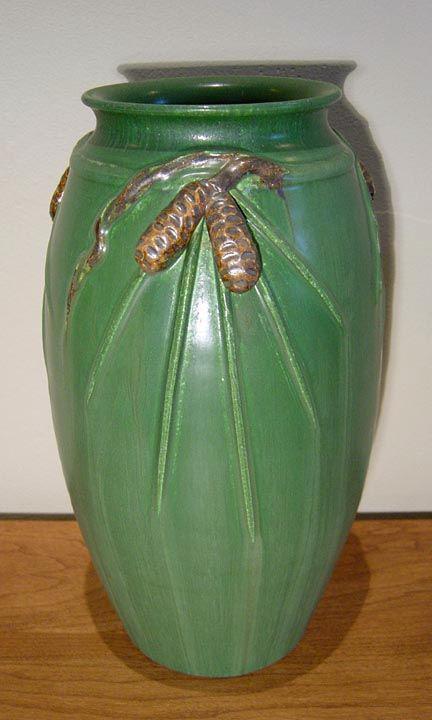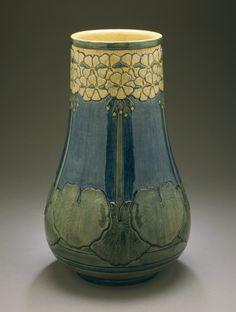The first image is the image on the left, the second image is the image on the right. Considering the images on both sides, is "In one image, a tall vase has an intricate faded green and yellow design with thin vertical elements running top to bottom, accented with small orange fan shapes." valid? Answer yes or no. No. The first image is the image on the left, the second image is the image on the right. Given the left and right images, does the statement "One of the vases is decorated with an illustrated design from top to bottom and shaped in a way that tapers to a smaller base." hold true? Answer yes or no. No. 